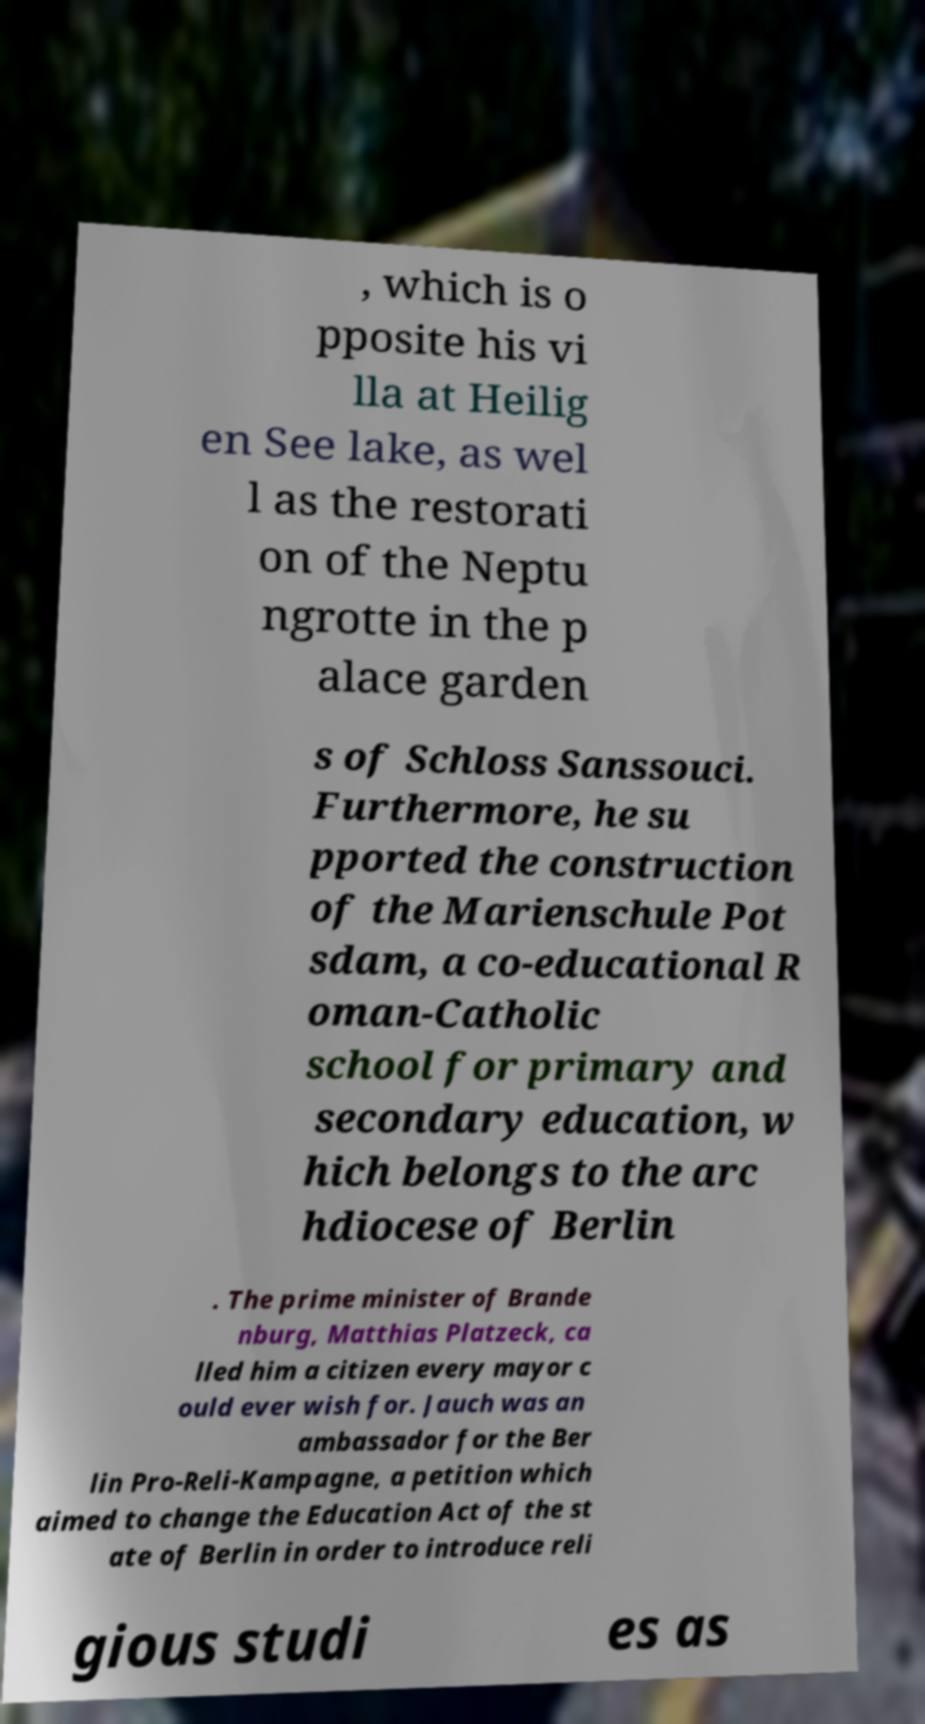Please identify and transcribe the text found in this image. , which is o pposite his vi lla at Heilig en See lake, as wel l as the restorati on of the Neptu ngrotte in the p alace garden s of Schloss Sanssouci. Furthermore, he su pported the construction of the Marienschule Pot sdam, a co-educational R oman-Catholic school for primary and secondary education, w hich belongs to the arc hdiocese of Berlin . The prime minister of Brande nburg, Matthias Platzeck, ca lled him a citizen every mayor c ould ever wish for. Jauch was an ambassador for the Ber lin Pro-Reli-Kampagne, a petition which aimed to change the Education Act of the st ate of Berlin in order to introduce reli gious studi es as 